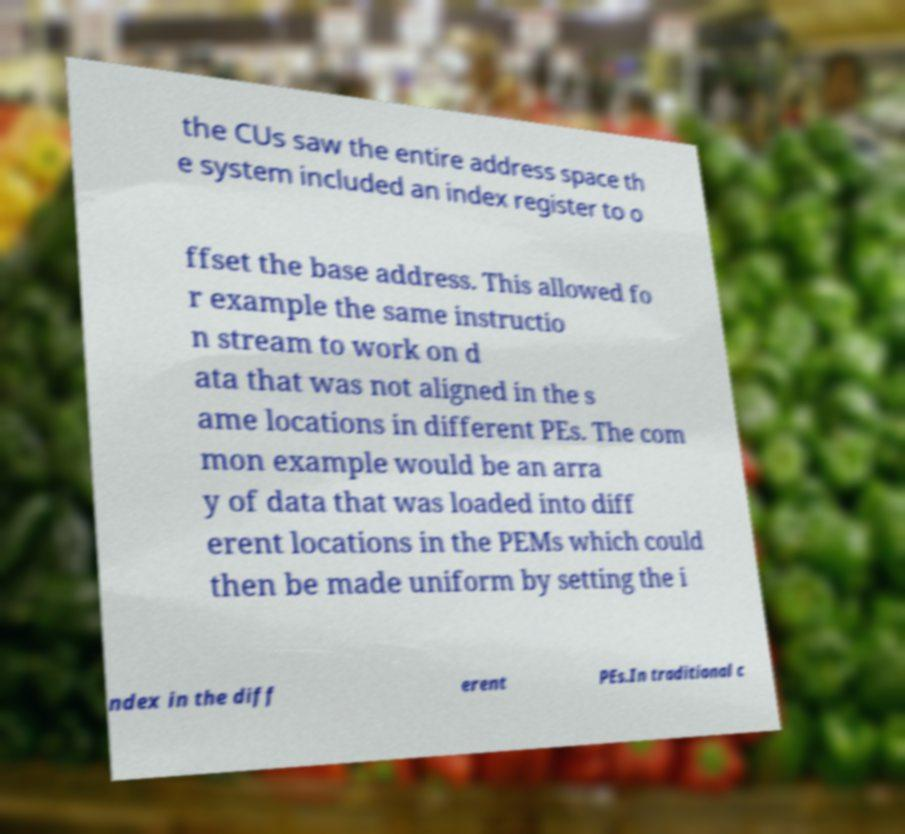Could you assist in decoding the text presented in this image and type it out clearly? the CUs saw the entire address space th e system included an index register to o ffset the base address. This allowed fo r example the same instructio n stream to work on d ata that was not aligned in the s ame locations in different PEs. The com mon example would be an arra y of data that was loaded into diff erent locations in the PEMs which could then be made uniform by setting the i ndex in the diff erent PEs.In traditional c 